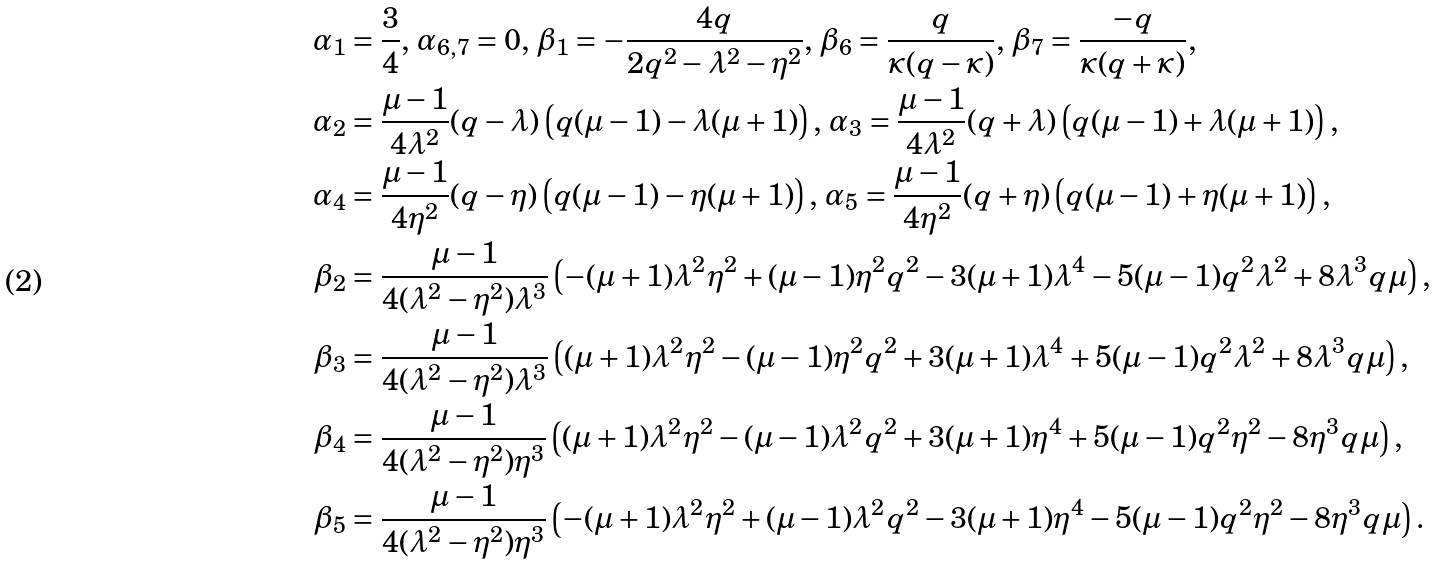Convert formula to latex. <formula><loc_0><loc_0><loc_500><loc_500>\alpha _ { 1 } & = \frac { 3 } { 4 } , \, \alpha _ { 6 , 7 } = 0 , \, \beta _ { 1 } = - \frac { 4 q } { 2 q ^ { 2 } - \lambda ^ { 2 } - \eta ^ { 2 } } , \, \beta _ { 6 } = \frac { q } { \varkappa ( q - \varkappa ) } , \, \beta _ { 7 } = \frac { - q } { \varkappa ( q + \varkappa ) } , \\ \alpha _ { 2 } & = \frac { \mu - 1 } { 4 \lambda ^ { 2 } } ( q - \lambda ) \left ( q ( \mu - 1 ) - \lambda ( \mu + 1 ) \right ) , \, \alpha _ { 3 } = \frac { \mu - 1 } { 4 \lambda ^ { 2 } } ( q + \lambda ) \left ( q ( \mu - 1 ) + \lambda ( \mu + 1 ) \right ) , \\ \alpha _ { 4 } & = \frac { \mu - 1 } { 4 \eta ^ { 2 } } ( q - \eta ) \left ( q ( \mu - 1 ) - \eta ( \mu + 1 ) \right ) , \, \alpha _ { 5 } = \frac { \mu - 1 } { 4 \eta ^ { 2 } } ( q + \eta ) \left ( q ( \mu - 1 ) + \eta ( \mu + 1 ) \right ) , \\ \beta _ { 2 } & = \frac { \mu - 1 } { 4 ( \lambda ^ { 2 } - \eta ^ { 2 } ) \lambda ^ { 3 } } \left ( - ( \mu + 1 ) \lambda ^ { 2 } \eta ^ { 2 } + ( \mu - 1 ) \eta ^ { 2 } q ^ { 2 } - 3 ( \mu + 1 ) \lambda ^ { 4 } - 5 ( \mu - 1 ) q ^ { 2 } \lambda ^ { 2 } + 8 \lambda ^ { 3 } q \mu \right ) , \\ \beta _ { 3 } & = \frac { \mu - 1 } { 4 ( \lambda ^ { 2 } - \eta ^ { 2 } ) \lambda ^ { 3 } } \left ( ( \mu + 1 ) \lambda ^ { 2 } \eta ^ { 2 } - ( \mu - 1 ) \eta ^ { 2 } q ^ { 2 } + 3 ( \mu + 1 ) \lambda ^ { 4 } + 5 ( \mu - 1 ) q ^ { 2 } \lambda ^ { 2 } + 8 \lambda ^ { 3 } q \mu \right ) , \\ \beta _ { 4 } & = \frac { \mu - 1 } { 4 ( \lambda ^ { 2 } - \eta ^ { 2 } ) \eta ^ { 3 } } \left ( ( \mu + 1 ) \lambda ^ { 2 } \eta ^ { 2 } - ( \mu - 1 ) \lambda ^ { 2 } q ^ { 2 } + 3 ( \mu + 1 ) \eta ^ { 4 } + 5 ( \mu - 1 ) q ^ { 2 } \eta ^ { 2 } - 8 \eta ^ { 3 } q \mu \right ) , \\ \beta _ { 5 } & = \frac { \mu - 1 } { 4 ( \lambda ^ { 2 } - \eta ^ { 2 } ) \eta ^ { 3 } } \left ( - ( \mu + 1 ) \lambda ^ { 2 } \eta ^ { 2 } + ( \mu - 1 ) \lambda ^ { 2 } q ^ { 2 } - 3 ( \mu + 1 ) \eta ^ { 4 } - 5 ( \mu - 1 ) q ^ { 2 } \eta ^ { 2 } - 8 \eta ^ { 3 } q \mu \right ) .</formula> 